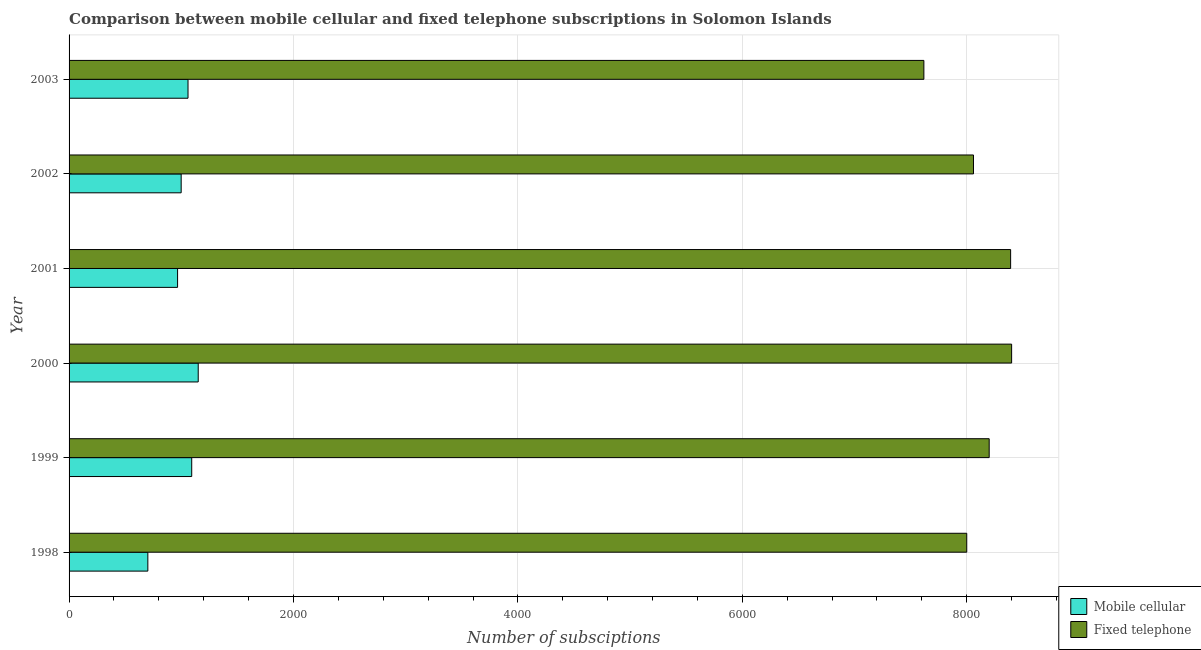What is the label of the 2nd group of bars from the top?
Your answer should be compact. 2002. What is the number of mobile cellular subscriptions in 1998?
Make the answer very short. 702. Across all years, what is the maximum number of fixed telephone subscriptions?
Make the answer very short. 8400. Across all years, what is the minimum number of mobile cellular subscriptions?
Provide a succinct answer. 702. In which year was the number of fixed telephone subscriptions maximum?
Keep it short and to the point. 2000. What is the total number of mobile cellular subscriptions in the graph?
Provide a short and direct response. 5972. What is the difference between the number of fixed telephone subscriptions in 2001 and that in 2003?
Your response must be concise. 773. What is the difference between the number of mobile cellular subscriptions in 2002 and the number of fixed telephone subscriptions in 2000?
Ensure brevity in your answer.  -7401. What is the average number of mobile cellular subscriptions per year?
Give a very brief answer. 995.33. In the year 1998, what is the difference between the number of fixed telephone subscriptions and number of mobile cellular subscriptions?
Provide a succinct answer. 7298. In how many years, is the number of fixed telephone subscriptions greater than 4000 ?
Your response must be concise. 6. Is the difference between the number of mobile cellular subscriptions in 2002 and 2003 greater than the difference between the number of fixed telephone subscriptions in 2002 and 2003?
Provide a succinct answer. No. What is the difference between the highest and the lowest number of mobile cellular subscriptions?
Keep it short and to the point. 449. In how many years, is the number of fixed telephone subscriptions greater than the average number of fixed telephone subscriptions taken over all years?
Provide a succinct answer. 3. What does the 2nd bar from the top in 2001 represents?
Provide a short and direct response. Mobile cellular. What does the 1st bar from the bottom in 1998 represents?
Keep it short and to the point. Mobile cellular. How many bars are there?
Provide a short and direct response. 12. Are all the bars in the graph horizontal?
Make the answer very short. Yes. Does the graph contain grids?
Ensure brevity in your answer.  Yes. Where does the legend appear in the graph?
Your answer should be compact. Bottom right. How are the legend labels stacked?
Your response must be concise. Vertical. What is the title of the graph?
Your answer should be very brief. Comparison between mobile cellular and fixed telephone subscriptions in Solomon Islands. What is the label or title of the X-axis?
Ensure brevity in your answer.  Number of subsciptions. What is the Number of subsciptions in Mobile cellular in 1998?
Offer a very short reply. 702. What is the Number of subsciptions in Fixed telephone in 1998?
Ensure brevity in your answer.  8000. What is the Number of subsciptions in Mobile cellular in 1999?
Offer a very short reply. 1093. What is the Number of subsciptions of Fixed telephone in 1999?
Offer a very short reply. 8200. What is the Number of subsciptions of Mobile cellular in 2000?
Your answer should be very brief. 1151. What is the Number of subsciptions of Fixed telephone in 2000?
Offer a terse response. 8400. What is the Number of subsciptions of Mobile cellular in 2001?
Give a very brief answer. 967. What is the Number of subsciptions of Fixed telephone in 2001?
Your answer should be compact. 8391. What is the Number of subsciptions of Mobile cellular in 2002?
Provide a short and direct response. 999. What is the Number of subsciptions in Fixed telephone in 2002?
Your answer should be very brief. 8060. What is the Number of subsciptions in Mobile cellular in 2003?
Your response must be concise. 1060. What is the Number of subsciptions of Fixed telephone in 2003?
Make the answer very short. 7618. Across all years, what is the maximum Number of subsciptions of Mobile cellular?
Offer a very short reply. 1151. Across all years, what is the maximum Number of subsciptions of Fixed telephone?
Provide a succinct answer. 8400. Across all years, what is the minimum Number of subsciptions in Mobile cellular?
Your response must be concise. 702. Across all years, what is the minimum Number of subsciptions in Fixed telephone?
Keep it short and to the point. 7618. What is the total Number of subsciptions in Mobile cellular in the graph?
Give a very brief answer. 5972. What is the total Number of subsciptions of Fixed telephone in the graph?
Offer a very short reply. 4.87e+04. What is the difference between the Number of subsciptions of Mobile cellular in 1998 and that in 1999?
Offer a terse response. -391. What is the difference between the Number of subsciptions in Fixed telephone in 1998 and that in 1999?
Your answer should be compact. -200. What is the difference between the Number of subsciptions of Mobile cellular in 1998 and that in 2000?
Provide a succinct answer. -449. What is the difference between the Number of subsciptions in Fixed telephone in 1998 and that in 2000?
Keep it short and to the point. -400. What is the difference between the Number of subsciptions in Mobile cellular in 1998 and that in 2001?
Ensure brevity in your answer.  -265. What is the difference between the Number of subsciptions in Fixed telephone in 1998 and that in 2001?
Your answer should be very brief. -391. What is the difference between the Number of subsciptions of Mobile cellular in 1998 and that in 2002?
Offer a very short reply. -297. What is the difference between the Number of subsciptions of Fixed telephone in 1998 and that in 2002?
Your answer should be compact. -60. What is the difference between the Number of subsciptions of Mobile cellular in 1998 and that in 2003?
Your response must be concise. -358. What is the difference between the Number of subsciptions in Fixed telephone in 1998 and that in 2003?
Provide a short and direct response. 382. What is the difference between the Number of subsciptions of Mobile cellular in 1999 and that in 2000?
Provide a succinct answer. -58. What is the difference between the Number of subsciptions in Fixed telephone in 1999 and that in 2000?
Your answer should be compact. -200. What is the difference between the Number of subsciptions in Mobile cellular in 1999 and that in 2001?
Offer a terse response. 126. What is the difference between the Number of subsciptions of Fixed telephone in 1999 and that in 2001?
Your answer should be compact. -191. What is the difference between the Number of subsciptions in Mobile cellular in 1999 and that in 2002?
Ensure brevity in your answer.  94. What is the difference between the Number of subsciptions in Fixed telephone in 1999 and that in 2002?
Give a very brief answer. 140. What is the difference between the Number of subsciptions in Mobile cellular in 1999 and that in 2003?
Make the answer very short. 33. What is the difference between the Number of subsciptions in Fixed telephone in 1999 and that in 2003?
Provide a short and direct response. 582. What is the difference between the Number of subsciptions of Mobile cellular in 2000 and that in 2001?
Your answer should be very brief. 184. What is the difference between the Number of subsciptions of Fixed telephone in 2000 and that in 2001?
Keep it short and to the point. 9. What is the difference between the Number of subsciptions in Mobile cellular in 2000 and that in 2002?
Your response must be concise. 152. What is the difference between the Number of subsciptions of Fixed telephone in 2000 and that in 2002?
Give a very brief answer. 340. What is the difference between the Number of subsciptions in Mobile cellular in 2000 and that in 2003?
Offer a terse response. 91. What is the difference between the Number of subsciptions in Fixed telephone in 2000 and that in 2003?
Make the answer very short. 782. What is the difference between the Number of subsciptions of Mobile cellular in 2001 and that in 2002?
Provide a short and direct response. -32. What is the difference between the Number of subsciptions of Fixed telephone in 2001 and that in 2002?
Provide a short and direct response. 331. What is the difference between the Number of subsciptions of Mobile cellular in 2001 and that in 2003?
Make the answer very short. -93. What is the difference between the Number of subsciptions of Fixed telephone in 2001 and that in 2003?
Give a very brief answer. 773. What is the difference between the Number of subsciptions in Mobile cellular in 2002 and that in 2003?
Provide a short and direct response. -61. What is the difference between the Number of subsciptions in Fixed telephone in 2002 and that in 2003?
Provide a succinct answer. 442. What is the difference between the Number of subsciptions in Mobile cellular in 1998 and the Number of subsciptions in Fixed telephone in 1999?
Offer a terse response. -7498. What is the difference between the Number of subsciptions of Mobile cellular in 1998 and the Number of subsciptions of Fixed telephone in 2000?
Your response must be concise. -7698. What is the difference between the Number of subsciptions in Mobile cellular in 1998 and the Number of subsciptions in Fixed telephone in 2001?
Provide a short and direct response. -7689. What is the difference between the Number of subsciptions in Mobile cellular in 1998 and the Number of subsciptions in Fixed telephone in 2002?
Offer a terse response. -7358. What is the difference between the Number of subsciptions of Mobile cellular in 1998 and the Number of subsciptions of Fixed telephone in 2003?
Your answer should be very brief. -6916. What is the difference between the Number of subsciptions of Mobile cellular in 1999 and the Number of subsciptions of Fixed telephone in 2000?
Ensure brevity in your answer.  -7307. What is the difference between the Number of subsciptions of Mobile cellular in 1999 and the Number of subsciptions of Fixed telephone in 2001?
Make the answer very short. -7298. What is the difference between the Number of subsciptions of Mobile cellular in 1999 and the Number of subsciptions of Fixed telephone in 2002?
Provide a short and direct response. -6967. What is the difference between the Number of subsciptions of Mobile cellular in 1999 and the Number of subsciptions of Fixed telephone in 2003?
Offer a terse response. -6525. What is the difference between the Number of subsciptions in Mobile cellular in 2000 and the Number of subsciptions in Fixed telephone in 2001?
Offer a very short reply. -7240. What is the difference between the Number of subsciptions of Mobile cellular in 2000 and the Number of subsciptions of Fixed telephone in 2002?
Your answer should be very brief. -6909. What is the difference between the Number of subsciptions in Mobile cellular in 2000 and the Number of subsciptions in Fixed telephone in 2003?
Your response must be concise. -6467. What is the difference between the Number of subsciptions in Mobile cellular in 2001 and the Number of subsciptions in Fixed telephone in 2002?
Your answer should be very brief. -7093. What is the difference between the Number of subsciptions of Mobile cellular in 2001 and the Number of subsciptions of Fixed telephone in 2003?
Give a very brief answer. -6651. What is the difference between the Number of subsciptions in Mobile cellular in 2002 and the Number of subsciptions in Fixed telephone in 2003?
Offer a very short reply. -6619. What is the average Number of subsciptions of Mobile cellular per year?
Offer a terse response. 995.33. What is the average Number of subsciptions in Fixed telephone per year?
Make the answer very short. 8111.5. In the year 1998, what is the difference between the Number of subsciptions in Mobile cellular and Number of subsciptions in Fixed telephone?
Provide a short and direct response. -7298. In the year 1999, what is the difference between the Number of subsciptions in Mobile cellular and Number of subsciptions in Fixed telephone?
Offer a very short reply. -7107. In the year 2000, what is the difference between the Number of subsciptions of Mobile cellular and Number of subsciptions of Fixed telephone?
Offer a very short reply. -7249. In the year 2001, what is the difference between the Number of subsciptions in Mobile cellular and Number of subsciptions in Fixed telephone?
Give a very brief answer. -7424. In the year 2002, what is the difference between the Number of subsciptions in Mobile cellular and Number of subsciptions in Fixed telephone?
Provide a succinct answer. -7061. In the year 2003, what is the difference between the Number of subsciptions in Mobile cellular and Number of subsciptions in Fixed telephone?
Provide a short and direct response. -6558. What is the ratio of the Number of subsciptions in Mobile cellular in 1998 to that in 1999?
Your answer should be compact. 0.64. What is the ratio of the Number of subsciptions in Fixed telephone in 1998 to that in 1999?
Make the answer very short. 0.98. What is the ratio of the Number of subsciptions of Mobile cellular in 1998 to that in 2000?
Your response must be concise. 0.61. What is the ratio of the Number of subsciptions of Mobile cellular in 1998 to that in 2001?
Your answer should be very brief. 0.73. What is the ratio of the Number of subsciptions in Fixed telephone in 1998 to that in 2001?
Your response must be concise. 0.95. What is the ratio of the Number of subsciptions in Mobile cellular in 1998 to that in 2002?
Offer a terse response. 0.7. What is the ratio of the Number of subsciptions of Fixed telephone in 1998 to that in 2002?
Provide a succinct answer. 0.99. What is the ratio of the Number of subsciptions in Mobile cellular in 1998 to that in 2003?
Offer a terse response. 0.66. What is the ratio of the Number of subsciptions of Fixed telephone in 1998 to that in 2003?
Ensure brevity in your answer.  1.05. What is the ratio of the Number of subsciptions of Mobile cellular in 1999 to that in 2000?
Ensure brevity in your answer.  0.95. What is the ratio of the Number of subsciptions of Fixed telephone in 1999 to that in 2000?
Offer a terse response. 0.98. What is the ratio of the Number of subsciptions in Mobile cellular in 1999 to that in 2001?
Give a very brief answer. 1.13. What is the ratio of the Number of subsciptions in Fixed telephone in 1999 to that in 2001?
Ensure brevity in your answer.  0.98. What is the ratio of the Number of subsciptions in Mobile cellular in 1999 to that in 2002?
Offer a very short reply. 1.09. What is the ratio of the Number of subsciptions of Fixed telephone in 1999 to that in 2002?
Offer a very short reply. 1.02. What is the ratio of the Number of subsciptions in Mobile cellular in 1999 to that in 2003?
Your answer should be very brief. 1.03. What is the ratio of the Number of subsciptions in Fixed telephone in 1999 to that in 2003?
Your response must be concise. 1.08. What is the ratio of the Number of subsciptions of Mobile cellular in 2000 to that in 2001?
Give a very brief answer. 1.19. What is the ratio of the Number of subsciptions in Fixed telephone in 2000 to that in 2001?
Ensure brevity in your answer.  1. What is the ratio of the Number of subsciptions in Mobile cellular in 2000 to that in 2002?
Keep it short and to the point. 1.15. What is the ratio of the Number of subsciptions in Fixed telephone in 2000 to that in 2002?
Provide a short and direct response. 1.04. What is the ratio of the Number of subsciptions of Mobile cellular in 2000 to that in 2003?
Keep it short and to the point. 1.09. What is the ratio of the Number of subsciptions of Fixed telephone in 2000 to that in 2003?
Provide a succinct answer. 1.1. What is the ratio of the Number of subsciptions of Fixed telephone in 2001 to that in 2002?
Your response must be concise. 1.04. What is the ratio of the Number of subsciptions of Mobile cellular in 2001 to that in 2003?
Your response must be concise. 0.91. What is the ratio of the Number of subsciptions of Fixed telephone in 2001 to that in 2003?
Offer a very short reply. 1.1. What is the ratio of the Number of subsciptions of Mobile cellular in 2002 to that in 2003?
Ensure brevity in your answer.  0.94. What is the ratio of the Number of subsciptions in Fixed telephone in 2002 to that in 2003?
Your response must be concise. 1.06. What is the difference between the highest and the second highest Number of subsciptions in Fixed telephone?
Ensure brevity in your answer.  9. What is the difference between the highest and the lowest Number of subsciptions of Mobile cellular?
Keep it short and to the point. 449. What is the difference between the highest and the lowest Number of subsciptions of Fixed telephone?
Provide a short and direct response. 782. 